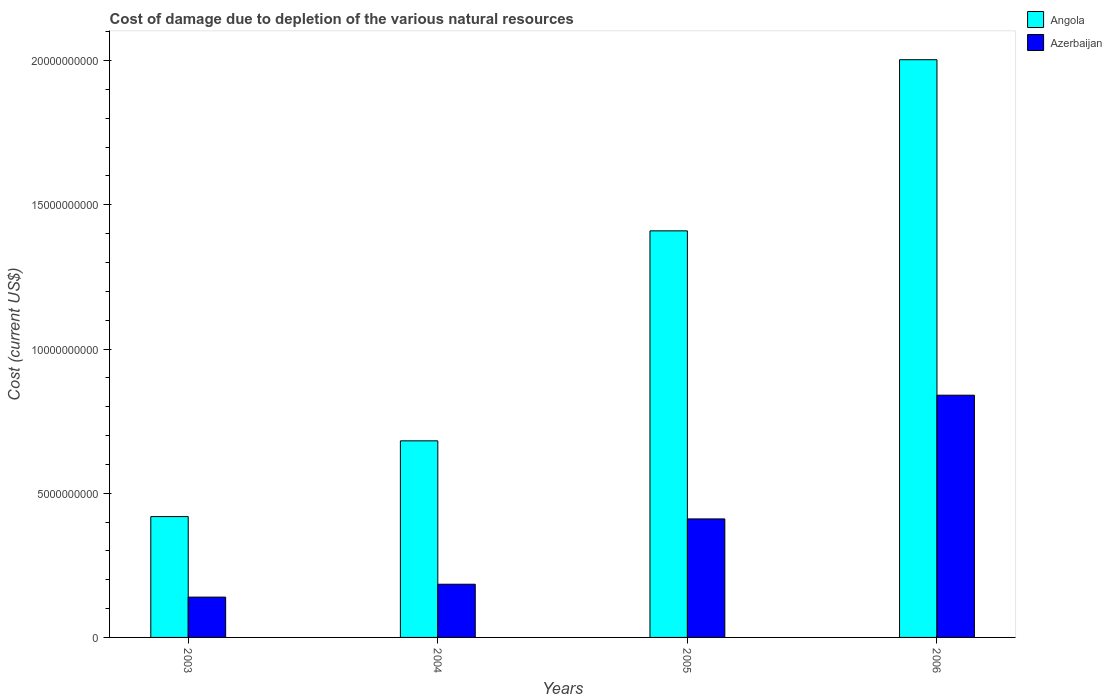How many different coloured bars are there?
Provide a succinct answer. 2. How many groups of bars are there?
Offer a very short reply. 4. Are the number of bars per tick equal to the number of legend labels?
Your response must be concise. Yes. How many bars are there on the 3rd tick from the left?
Your answer should be compact. 2. How many bars are there on the 2nd tick from the right?
Provide a short and direct response. 2. In how many cases, is the number of bars for a given year not equal to the number of legend labels?
Provide a short and direct response. 0. What is the cost of damage caused due to the depletion of various natural resources in Azerbaijan in 2005?
Your answer should be compact. 4.11e+09. Across all years, what is the maximum cost of damage caused due to the depletion of various natural resources in Angola?
Your answer should be compact. 2.00e+1. Across all years, what is the minimum cost of damage caused due to the depletion of various natural resources in Angola?
Offer a very short reply. 4.19e+09. What is the total cost of damage caused due to the depletion of various natural resources in Angola in the graph?
Provide a succinct answer. 4.51e+1. What is the difference between the cost of damage caused due to the depletion of various natural resources in Azerbaijan in 2003 and that in 2005?
Your answer should be very brief. -2.71e+09. What is the difference between the cost of damage caused due to the depletion of various natural resources in Angola in 2006 and the cost of damage caused due to the depletion of various natural resources in Azerbaijan in 2004?
Your answer should be very brief. 1.82e+1. What is the average cost of damage caused due to the depletion of various natural resources in Angola per year?
Offer a terse response. 1.13e+1. In the year 2005, what is the difference between the cost of damage caused due to the depletion of various natural resources in Azerbaijan and cost of damage caused due to the depletion of various natural resources in Angola?
Ensure brevity in your answer.  -9.99e+09. In how many years, is the cost of damage caused due to the depletion of various natural resources in Angola greater than 13000000000 US$?
Ensure brevity in your answer.  2. What is the ratio of the cost of damage caused due to the depletion of various natural resources in Angola in 2003 to that in 2006?
Keep it short and to the point. 0.21. Is the cost of damage caused due to the depletion of various natural resources in Angola in 2004 less than that in 2006?
Offer a terse response. Yes. What is the difference between the highest and the second highest cost of damage caused due to the depletion of various natural resources in Azerbaijan?
Your answer should be very brief. 4.29e+09. What is the difference between the highest and the lowest cost of damage caused due to the depletion of various natural resources in Azerbaijan?
Provide a succinct answer. 7.00e+09. What does the 1st bar from the left in 2005 represents?
Your answer should be compact. Angola. What does the 2nd bar from the right in 2005 represents?
Ensure brevity in your answer.  Angola. How many bars are there?
Your response must be concise. 8. How many years are there in the graph?
Offer a very short reply. 4. Are the values on the major ticks of Y-axis written in scientific E-notation?
Your answer should be very brief. No. Does the graph contain any zero values?
Your response must be concise. No. What is the title of the graph?
Make the answer very short. Cost of damage due to depletion of the various natural resources. Does "Turks and Caicos Islands" appear as one of the legend labels in the graph?
Give a very brief answer. No. What is the label or title of the Y-axis?
Ensure brevity in your answer.  Cost (current US$). What is the Cost (current US$) in Angola in 2003?
Make the answer very short. 4.19e+09. What is the Cost (current US$) of Azerbaijan in 2003?
Your response must be concise. 1.40e+09. What is the Cost (current US$) of Angola in 2004?
Make the answer very short. 6.82e+09. What is the Cost (current US$) in Azerbaijan in 2004?
Your response must be concise. 1.84e+09. What is the Cost (current US$) of Angola in 2005?
Your answer should be compact. 1.41e+1. What is the Cost (current US$) of Azerbaijan in 2005?
Make the answer very short. 4.11e+09. What is the Cost (current US$) of Angola in 2006?
Offer a very short reply. 2.00e+1. What is the Cost (current US$) in Azerbaijan in 2006?
Make the answer very short. 8.40e+09. Across all years, what is the maximum Cost (current US$) in Angola?
Provide a succinct answer. 2.00e+1. Across all years, what is the maximum Cost (current US$) of Azerbaijan?
Make the answer very short. 8.40e+09. Across all years, what is the minimum Cost (current US$) of Angola?
Keep it short and to the point. 4.19e+09. Across all years, what is the minimum Cost (current US$) of Azerbaijan?
Give a very brief answer. 1.40e+09. What is the total Cost (current US$) of Angola in the graph?
Offer a terse response. 4.51e+1. What is the total Cost (current US$) of Azerbaijan in the graph?
Ensure brevity in your answer.  1.58e+1. What is the difference between the Cost (current US$) in Angola in 2003 and that in 2004?
Provide a succinct answer. -2.63e+09. What is the difference between the Cost (current US$) in Azerbaijan in 2003 and that in 2004?
Your answer should be very brief. -4.47e+08. What is the difference between the Cost (current US$) in Angola in 2003 and that in 2005?
Your answer should be very brief. -9.91e+09. What is the difference between the Cost (current US$) of Azerbaijan in 2003 and that in 2005?
Provide a succinct answer. -2.71e+09. What is the difference between the Cost (current US$) of Angola in 2003 and that in 2006?
Offer a very short reply. -1.58e+1. What is the difference between the Cost (current US$) of Azerbaijan in 2003 and that in 2006?
Make the answer very short. -7.00e+09. What is the difference between the Cost (current US$) of Angola in 2004 and that in 2005?
Ensure brevity in your answer.  -7.28e+09. What is the difference between the Cost (current US$) in Azerbaijan in 2004 and that in 2005?
Your answer should be very brief. -2.27e+09. What is the difference between the Cost (current US$) of Angola in 2004 and that in 2006?
Your answer should be compact. -1.32e+1. What is the difference between the Cost (current US$) of Azerbaijan in 2004 and that in 2006?
Give a very brief answer. -6.56e+09. What is the difference between the Cost (current US$) in Angola in 2005 and that in 2006?
Your response must be concise. -5.93e+09. What is the difference between the Cost (current US$) in Azerbaijan in 2005 and that in 2006?
Ensure brevity in your answer.  -4.29e+09. What is the difference between the Cost (current US$) in Angola in 2003 and the Cost (current US$) in Azerbaijan in 2004?
Your response must be concise. 2.35e+09. What is the difference between the Cost (current US$) of Angola in 2003 and the Cost (current US$) of Azerbaijan in 2005?
Your response must be concise. 8.06e+07. What is the difference between the Cost (current US$) in Angola in 2003 and the Cost (current US$) in Azerbaijan in 2006?
Your answer should be very brief. -4.21e+09. What is the difference between the Cost (current US$) in Angola in 2004 and the Cost (current US$) in Azerbaijan in 2005?
Your answer should be very brief. 2.71e+09. What is the difference between the Cost (current US$) of Angola in 2004 and the Cost (current US$) of Azerbaijan in 2006?
Provide a short and direct response. -1.58e+09. What is the difference between the Cost (current US$) of Angola in 2005 and the Cost (current US$) of Azerbaijan in 2006?
Your answer should be compact. 5.70e+09. What is the average Cost (current US$) in Angola per year?
Your answer should be compact. 1.13e+1. What is the average Cost (current US$) in Azerbaijan per year?
Offer a very short reply. 3.94e+09. In the year 2003, what is the difference between the Cost (current US$) of Angola and Cost (current US$) of Azerbaijan?
Your answer should be very brief. 2.79e+09. In the year 2004, what is the difference between the Cost (current US$) in Angola and Cost (current US$) in Azerbaijan?
Offer a terse response. 4.97e+09. In the year 2005, what is the difference between the Cost (current US$) of Angola and Cost (current US$) of Azerbaijan?
Your response must be concise. 9.99e+09. In the year 2006, what is the difference between the Cost (current US$) in Angola and Cost (current US$) in Azerbaijan?
Provide a succinct answer. 1.16e+1. What is the ratio of the Cost (current US$) of Angola in 2003 to that in 2004?
Keep it short and to the point. 0.61. What is the ratio of the Cost (current US$) of Azerbaijan in 2003 to that in 2004?
Offer a terse response. 0.76. What is the ratio of the Cost (current US$) of Angola in 2003 to that in 2005?
Provide a short and direct response. 0.3. What is the ratio of the Cost (current US$) in Azerbaijan in 2003 to that in 2005?
Offer a terse response. 0.34. What is the ratio of the Cost (current US$) in Angola in 2003 to that in 2006?
Make the answer very short. 0.21. What is the ratio of the Cost (current US$) of Azerbaijan in 2003 to that in 2006?
Your answer should be very brief. 0.17. What is the ratio of the Cost (current US$) of Angola in 2004 to that in 2005?
Make the answer very short. 0.48. What is the ratio of the Cost (current US$) in Azerbaijan in 2004 to that in 2005?
Provide a short and direct response. 0.45. What is the ratio of the Cost (current US$) of Angola in 2004 to that in 2006?
Provide a succinct answer. 0.34. What is the ratio of the Cost (current US$) of Azerbaijan in 2004 to that in 2006?
Your answer should be compact. 0.22. What is the ratio of the Cost (current US$) of Angola in 2005 to that in 2006?
Provide a succinct answer. 0.7. What is the ratio of the Cost (current US$) in Azerbaijan in 2005 to that in 2006?
Offer a very short reply. 0.49. What is the difference between the highest and the second highest Cost (current US$) of Angola?
Provide a short and direct response. 5.93e+09. What is the difference between the highest and the second highest Cost (current US$) in Azerbaijan?
Give a very brief answer. 4.29e+09. What is the difference between the highest and the lowest Cost (current US$) in Angola?
Keep it short and to the point. 1.58e+1. What is the difference between the highest and the lowest Cost (current US$) of Azerbaijan?
Keep it short and to the point. 7.00e+09. 